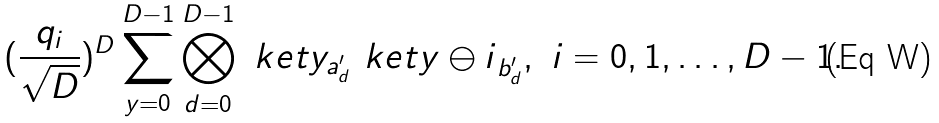Convert formula to latex. <formula><loc_0><loc_0><loc_500><loc_500>( \frac { q _ { i } } { \sqrt { D } } ) ^ { D } \sum _ { y = 0 } ^ { D - 1 } \bigotimes _ { d = 0 } ^ { D - 1 } \ k e t { y } _ { a ^ { \prime } _ { d } } \ k e t { y \ominus i } _ { b ^ { \prime } _ { d } } , \ i = 0 , 1 , \dots , D - 1 .</formula> 